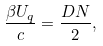<formula> <loc_0><loc_0><loc_500><loc_500>\frac { \beta U _ { q } } { c } = \frac { D N } { 2 } ,</formula> 